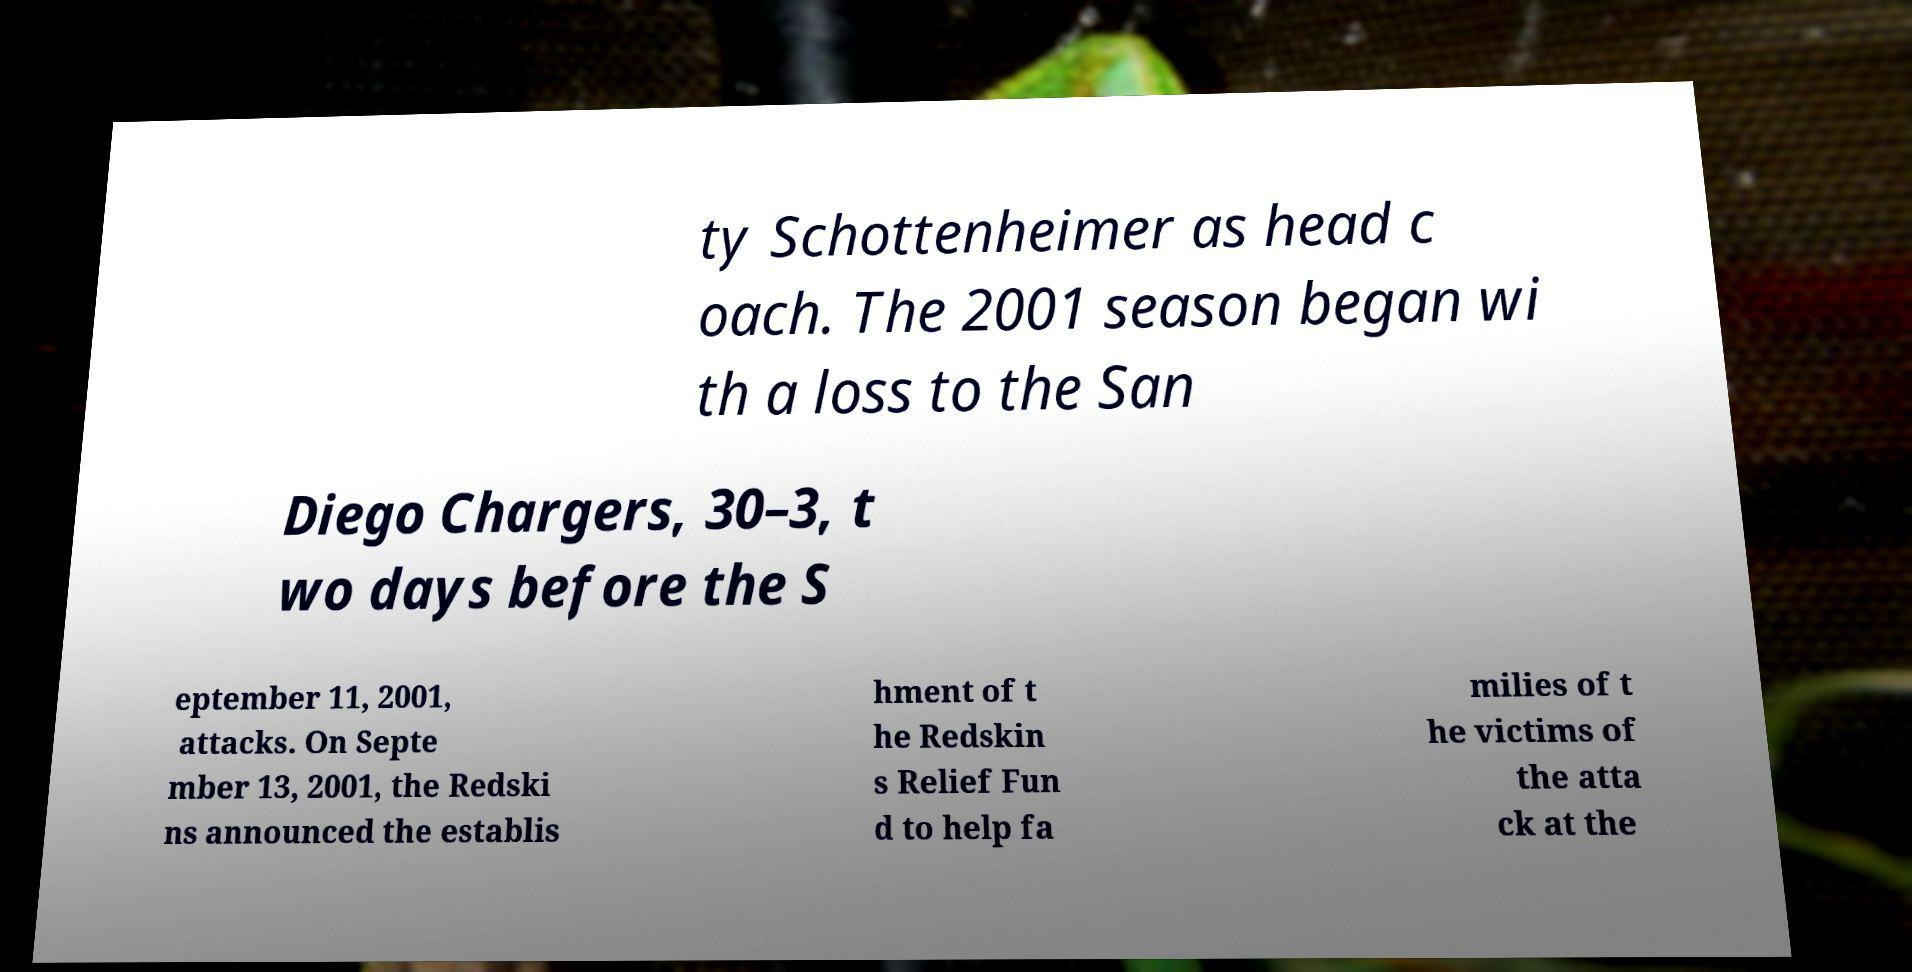Could you extract and type out the text from this image? ty Schottenheimer as head c oach. The 2001 season began wi th a loss to the San Diego Chargers, 30–3, t wo days before the S eptember 11, 2001, attacks. On Septe mber 13, 2001, the Redski ns announced the establis hment of t he Redskin s Relief Fun d to help fa milies of t he victims of the atta ck at the 